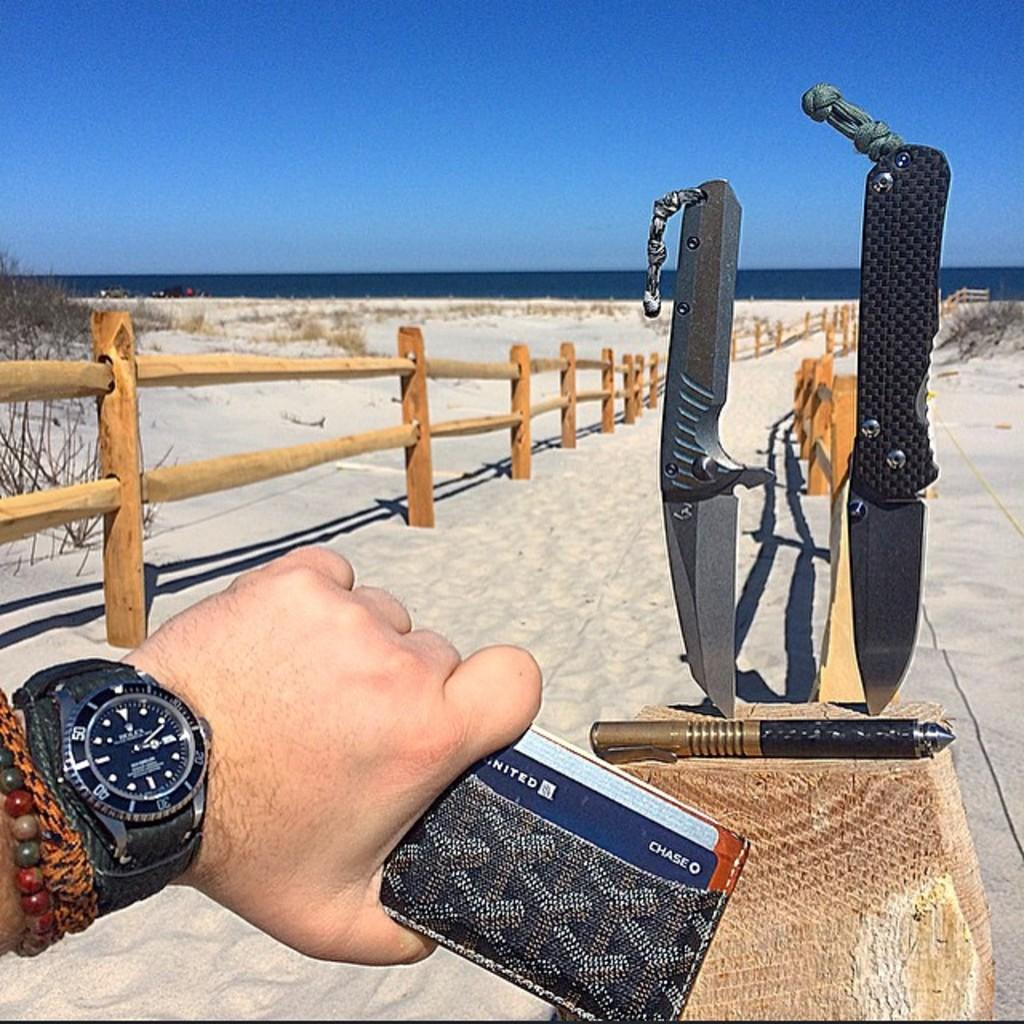<image>
Offer a succinct explanation of the picture presented. Person looking at their wristwatch while holding a wallet and the card CHASE inside. 